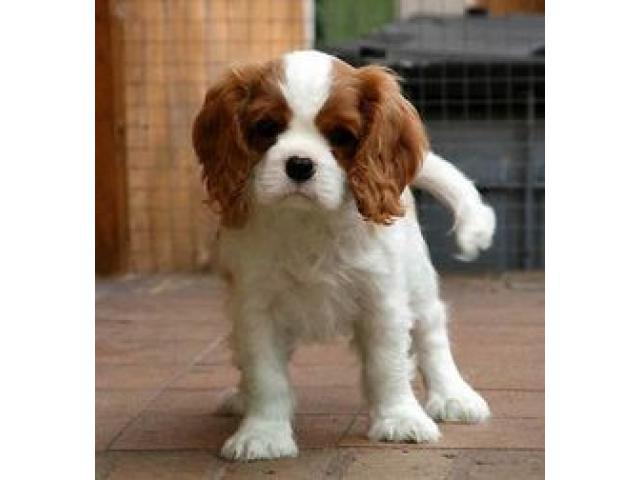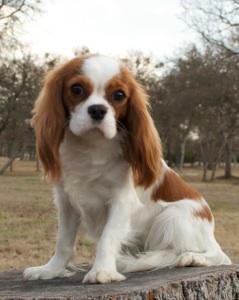The first image is the image on the left, the second image is the image on the right. Given the left and right images, does the statement "There are no more than three dogs." hold true? Answer yes or no. Yes. The first image is the image on the left, the second image is the image on the right. For the images displayed, is the sentence "There are no more than three dogs." factually correct? Answer yes or no. Yes. 